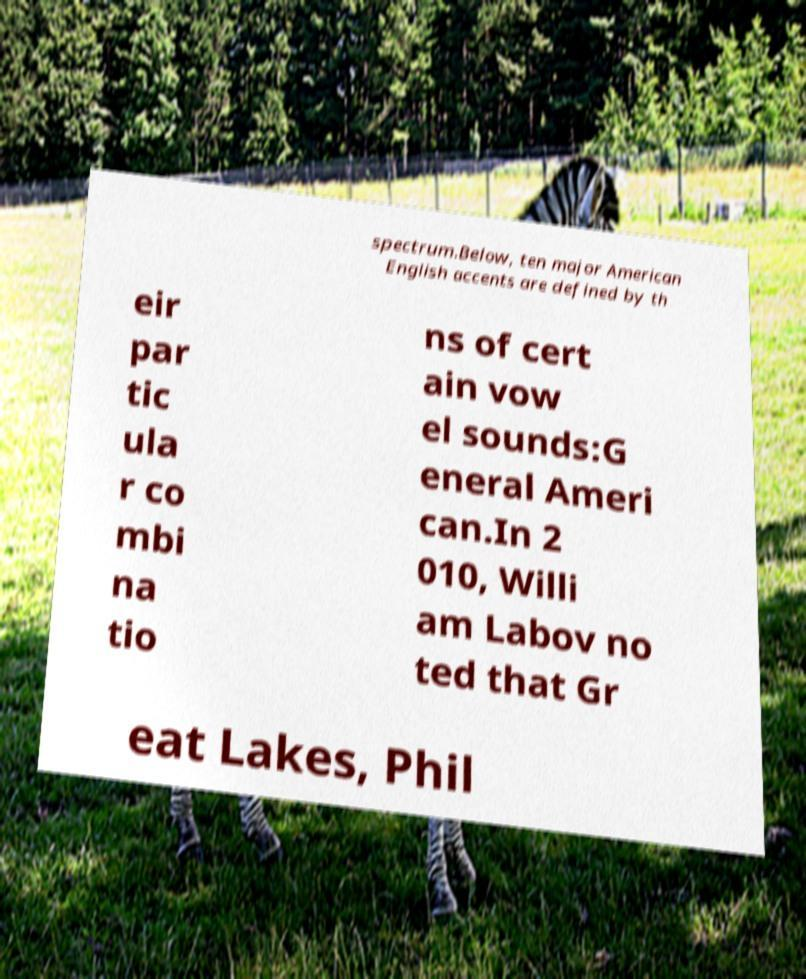Could you assist in decoding the text presented in this image and type it out clearly? spectrum.Below, ten major American English accents are defined by th eir par tic ula r co mbi na tio ns of cert ain vow el sounds:G eneral Ameri can.In 2 010, Willi am Labov no ted that Gr eat Lakes, Phil 